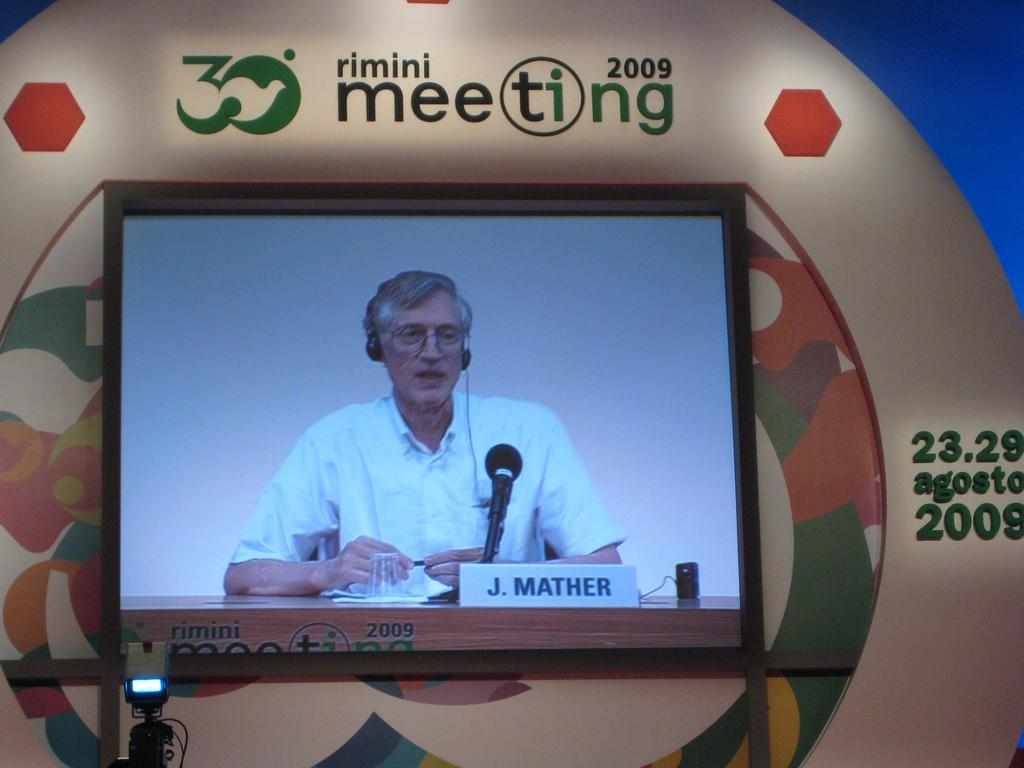Provide a one-sentence caption for the provided image. J. Mather taking to people at the rimini meeting in 2009. 